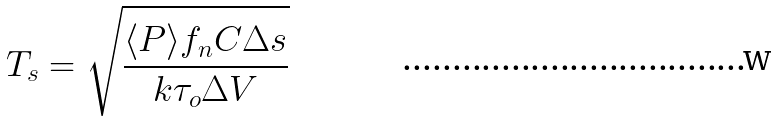Convert formula to latex. <formula><loc_0><loc_0><loc_500><loc_500>T _ { s } = \sqrt { \frac { \langle P \rangle f _ { n } C \Delta s } { k \tau _ { o } \Delta V } }</formula> 